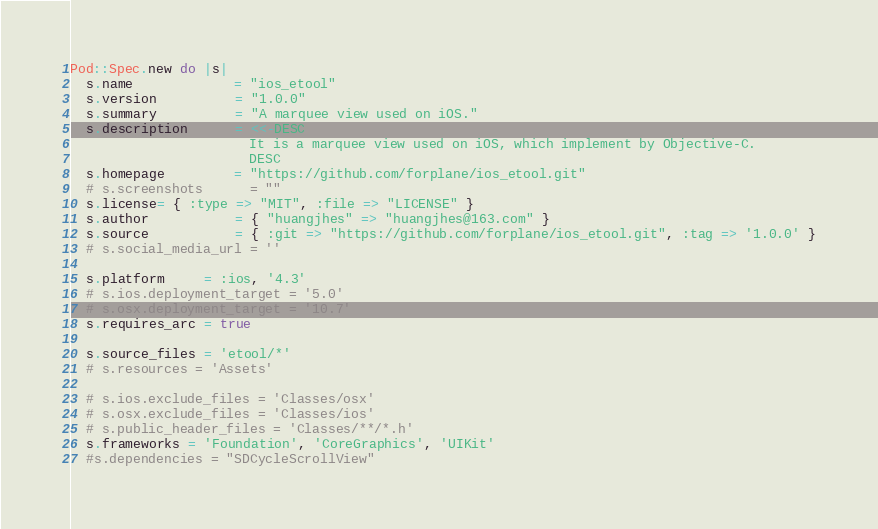Convert code to text. <code><loc_0><loc_0><loc_500><loc_500><_Ruby_>Pod::Spec.new do |s|
  s.name             = "ios_etool"
  s.version          = "1.0.0"
  s.summary          = "A marquee view used on iOS."
  s.description      = <<-DESC
                       It is a marquee view used on iOS, which implement by Objective-C.
                       DESC
  s.homepage         = "https://github.com/forplane/ios_etool.git"
  # s.screenshots      = ""
  s.license= { :type => "MIT", :file => "LICENSE" }
  s.author           = { "huangjhes" => "huangjhes@163.com" }
  s.source           = { :git => "https://github.com/forplane/ios_etool.git", :tag => '1.0.0' }
  # s.social_media_url = ''

  s.platform     = :ios, '4.3'
  # s.ios.deployment_target = '5.0'
  # s.osx.deployment_target = '10.7'
  s.requires_arc = true

  s.source_files = 'etool/*'
  # s.resources = 'Assets'

  # s.ios.exclude_files = 'Classes/osx'
  # s.osx.exclude_files = 'Classes/ios'
  # s.public_header_files = 'Classes/**/*.h'
  s.frameworks = 'Foundation', 'CoreGraphics', 'UIKit'
  #s.dependencies = "SDCycleScrollView"</code> 